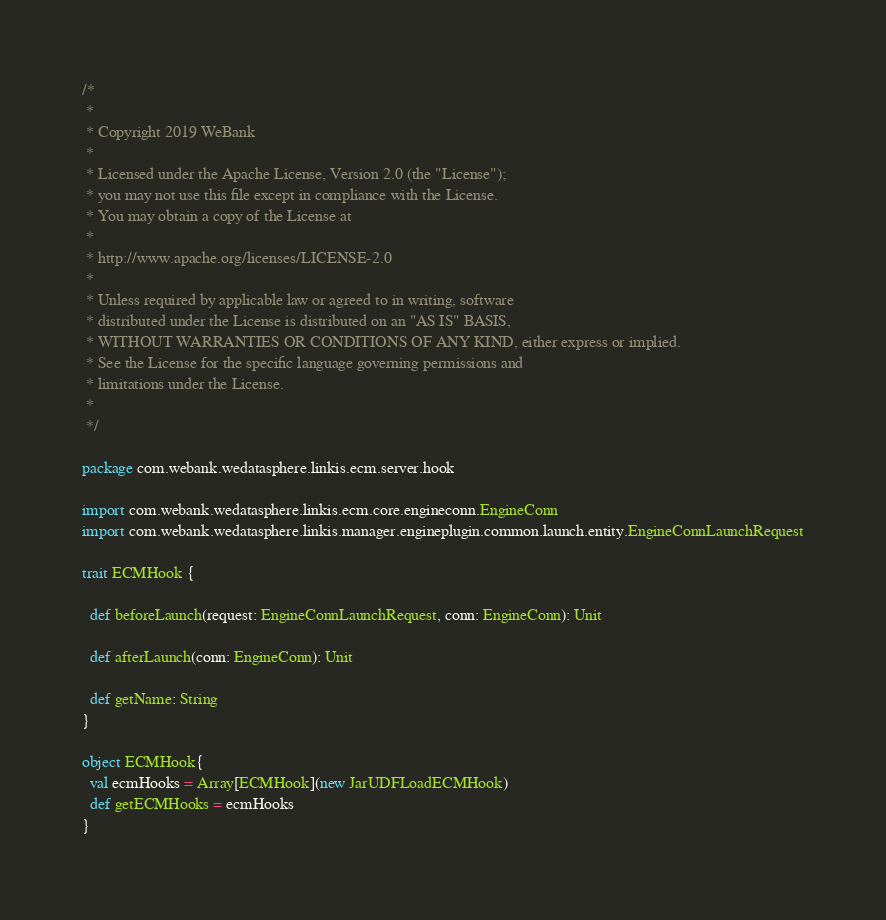<code> <loc_0><loc_0><loc_500><loc_500><_Scala_>/*
 *
 * Copyright 2019 WeBank
 *
 * Licensed under the Apache License, Version 2.0 (the "License");
 * you may not use this file except in compliance with the License.
 * You may obtain a copy of the License at
 *
 * http://www.apache.org/licenses/LICENSE-2.0
 *
 * Unless required by applicable law or agreed to in writing, software
 * distributed under the License is distributed on an "AS IS" BASIS,
 * WITHOUT WARRANTIES OR CONDITIONS OF ANY KIND, either express or implied.
 * See the License for the specific language governing permissions and
 * limitations under the License.
 *
 */

package com.webank.wedatasphere.linkis.ecm.server.hook

import com.webank.wedatasphere.linkis.ecm.core.engineconn.EngineConn
import com.webank.wedatasphere.linkis.manager.engineplugin.common.launch.entity.EngineConnLaunchRequest

trait ECMHook {

  def beforeLaunch(request: EngineConnLaunchRequest, conn: EngineConn): Unit

  def afterLaunch(conn: EngineConn): Unit

  def getName: String
}

object ECMHook{
  val ecmHooks = Array[ECMHook](new JarUDFLoadECMHook)
  def getECMHooks = ecmHooks
}
</code> 